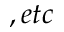Convert formula to latex. <formula><loc_0><loc_0><loc_500><loc_500>, e t c</formula> 